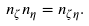Convert formula to latex. <formula><loc_0><loc_0><loc_500><loc_500>n _ { \zeta } n _ { \eta } = n _ { \zeta \eta } .</formula> 